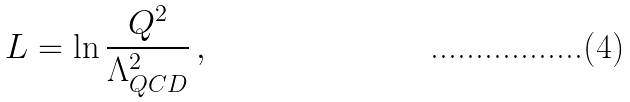Convert formula to latex. <formula><loc_0><loc_0><loc_500><loc_500>L = \ln \frac { Q ^ { 2 } } { \Lambda _ { Q C D } ^ { 2 } } \, ,</formula> 